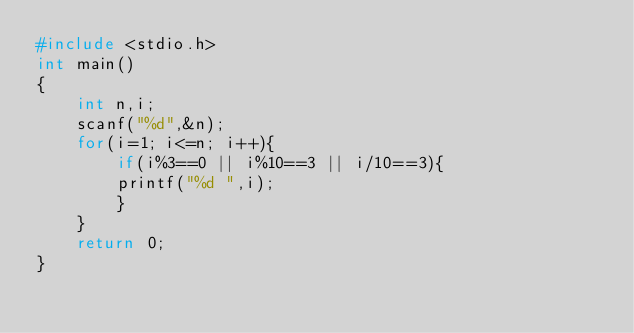<code> <loc_0><loc_0><loc_500><loc_500><_C_>#include <stdio.h>
int main()
{
	int n,i;
	scanf("%d",&n);	
	for(i=1; i<=n; i++){
		if(i%3==0 || i%10==3 || i/10==3){
		printf("%d ",i);
		}
	}
	return 0;
}</code> 